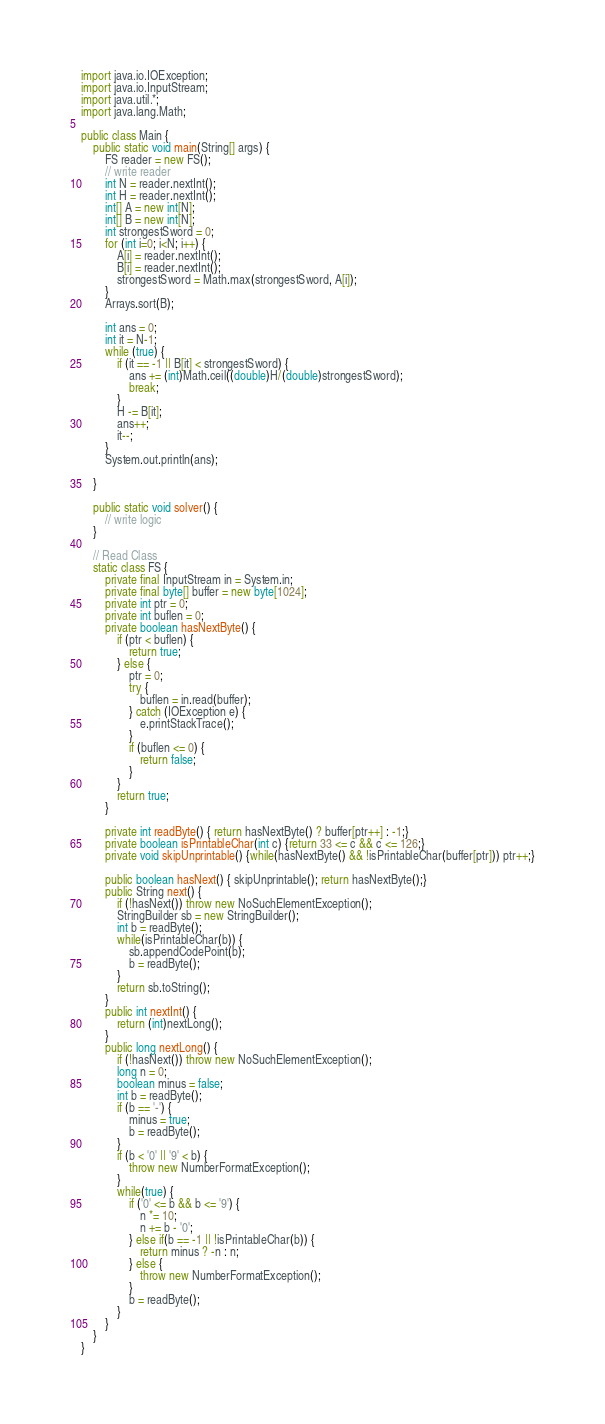Convert code to text. <code><loc_0><loc_0><loc_500><loc_500><_Java_>import java.io.IOException;
import java.io.InputStream;
import java.util.*;
import java.lang.Math;

public class Main {
    public static void main(String[] args) {
        FS reader = new FS();
        // write reader
        int N = reader.nextInt();
        int H = reader.nextInt();
        int[] A = new int[N];
        int[] B = new int[N];
        int strongestSword = 0;
        for (int i=0; i<N; i++) {
            A[i] = reader.nextInt();
            B[i] = reader.nextInt();
            strongestSword = Math.max(strongestSword, A[i]);
        }
        Arrays.sort(B);

        int ans = 0;
        int it = N-1;
        while (true) {
            if (it == -1 || B[it] < strongestSword) {
                ans += (int)Math.ceil((double)H/(double)strongestSword);
                break;
            }
            H -= B[it];
            ans++;
            it--;
        }
        System.out.println(ans);
        
    }
    
    public static void solver() {
        // write logic
    }
    
    // Read Class
    static class FS {
        private final InputStream in = System.in;
        private final byte[] buffer = new byte[1024];
        private int ptr = 0;
        private int buflen = 0;
        private boolean hasNextByte() {
            if (ptr < buflen) {
                return true;
            } else {
                ptr = 0;
                try {
                    buflen = in.read(buffer);
                } catch (IOException e) {
                    e.printStackTrace();
                }
                if (buflen <= 0) {
                    return false;
                }
            }
            return true;
        }
    
        private int readByte() { return hasNextByte() ? buffer[ptr++] : -1;}
        private boolean isPrintableChar(int c) {return 33 <= c && c <= 126;}
        private void skipUnprintable() {while(hasNextByte() && !isPrintableChar(buffer[ptr])) ptr++;}
    
        public boolean hasNext() { skipUnprintable(); return hasNextByte();}
        public String next() {
            if (!hasNext()) throw new NoSuchElementException();
            StringBuilder sb = new StringBuilder();
            int b = readByte();
            while(isPrintableChar(b)) {
                sb.appendCodePoint(b);
                b = readByte();
            }
            return sb.toString();
        }
        public int nextInt() {
            return (int)nextLong();
        }
        public long nextLong() {
            if (!hasNext()) throw new NoSuchElementException();
            long n = 0;
            boolean minus = false;
            int b = readByte();
            if (b == '-') {
                minus = true;
                b = readByte();
            }
            if (b < '0' || '9' < b) {
                throw new NumberFormatException();
            }
            while(true) {
                if ('0' <= b && b <= '9') {
                    n *= 10;
                    n += b - '0';
                } else if(b == -1 || !isPrintableChar(b)) {
                    return minus ? -n : n;
                } else {
                    throw new NumberFormatException();
                }
                b = readByte();
            }
        }
    }
}

</code> 